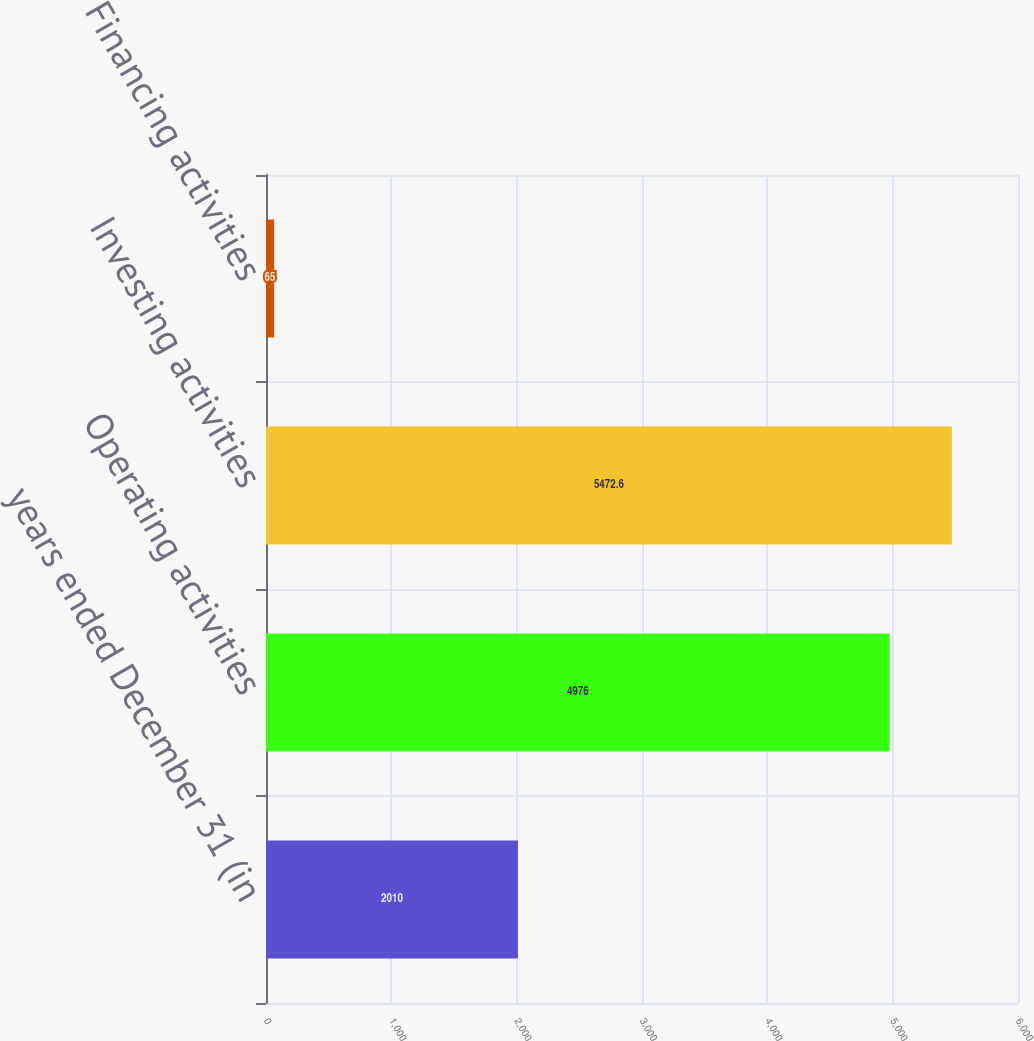Convert chart. <chart><loc_0><loc_0><loc_500><loc_500><bar_chart><fcel>years ended December 31 (in<fcel>Operating activities<fcel>Investing activities<fcel>Financing activities<nl><fcel>2010<fcel>4976<fcel>5472.6<fcel>65<nl></chart> 